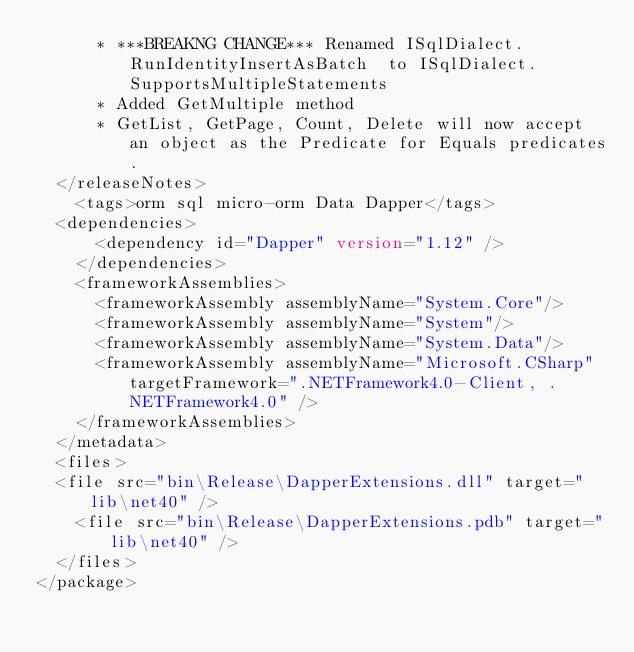<code> <loc_0><loc_0><loc_500><loc_500><_XML_>			* ***BREAKNG CHANGE*** Renamed ISqlDialect.RunIdentityInsertAsBatch  to ISqlDialect.SupportsMultipleStatements
			* Added GetMultiple method
			* GetList, GetPage, Count, Delete will now accept an object as the Predicate for Equals predicates.
	</releaseNotes>
    <tags>orm sql micro-orm Data Dapper</tags>
	<dependencies>
      <dependency id="Dapper" version="1.12" />
    </dependencies>
    <frameworkAssemblies>
      <frameworkAssembly assemblyName="System.Core"/>
      <frameworkAssembly assemblyName="System"/>
      <frameworkAssembly assemblyName="System.Data"/>
      <frameworkAssembly assemblyName="Microsoft.CSharp" targetFramework=".NETFramework4.0-Client, .NETFramework4.0" />
    </frameworkAssemblies>
  </metadata>
  <files>
	<file src="bin\Release\DapperExtensions.dll" target="lib\net40" />
    <file src="bin\Release\DapperExtensions.pdb" target="lib\net40" />
  </files>  
</package></code> 